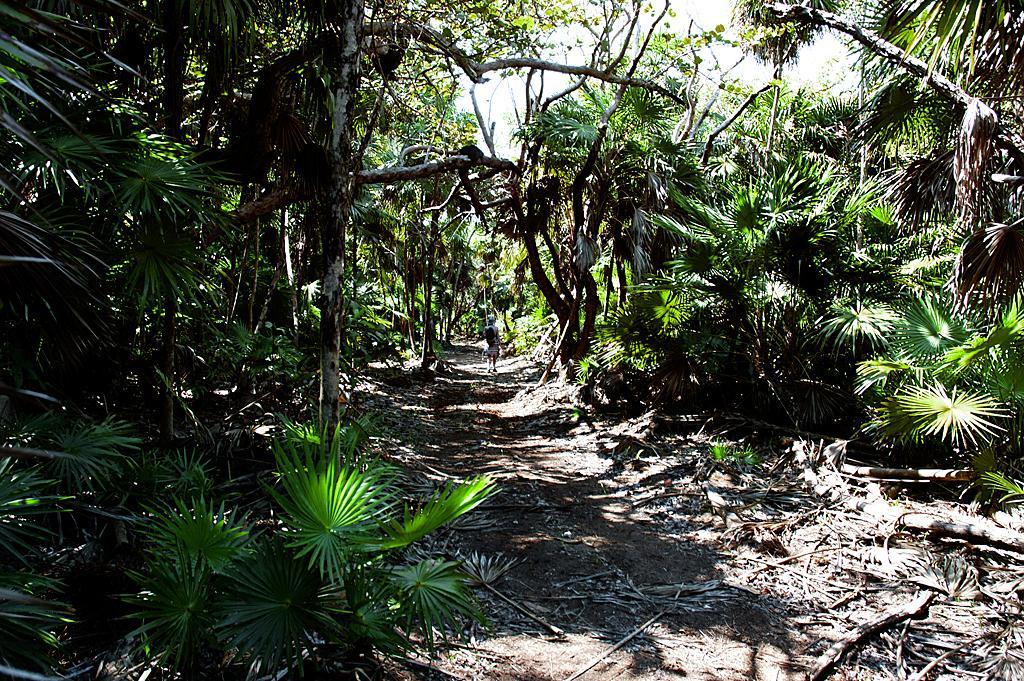Please provide a concise description of this image. In this picture I can see plants, trees, and in the background there is the sky. 